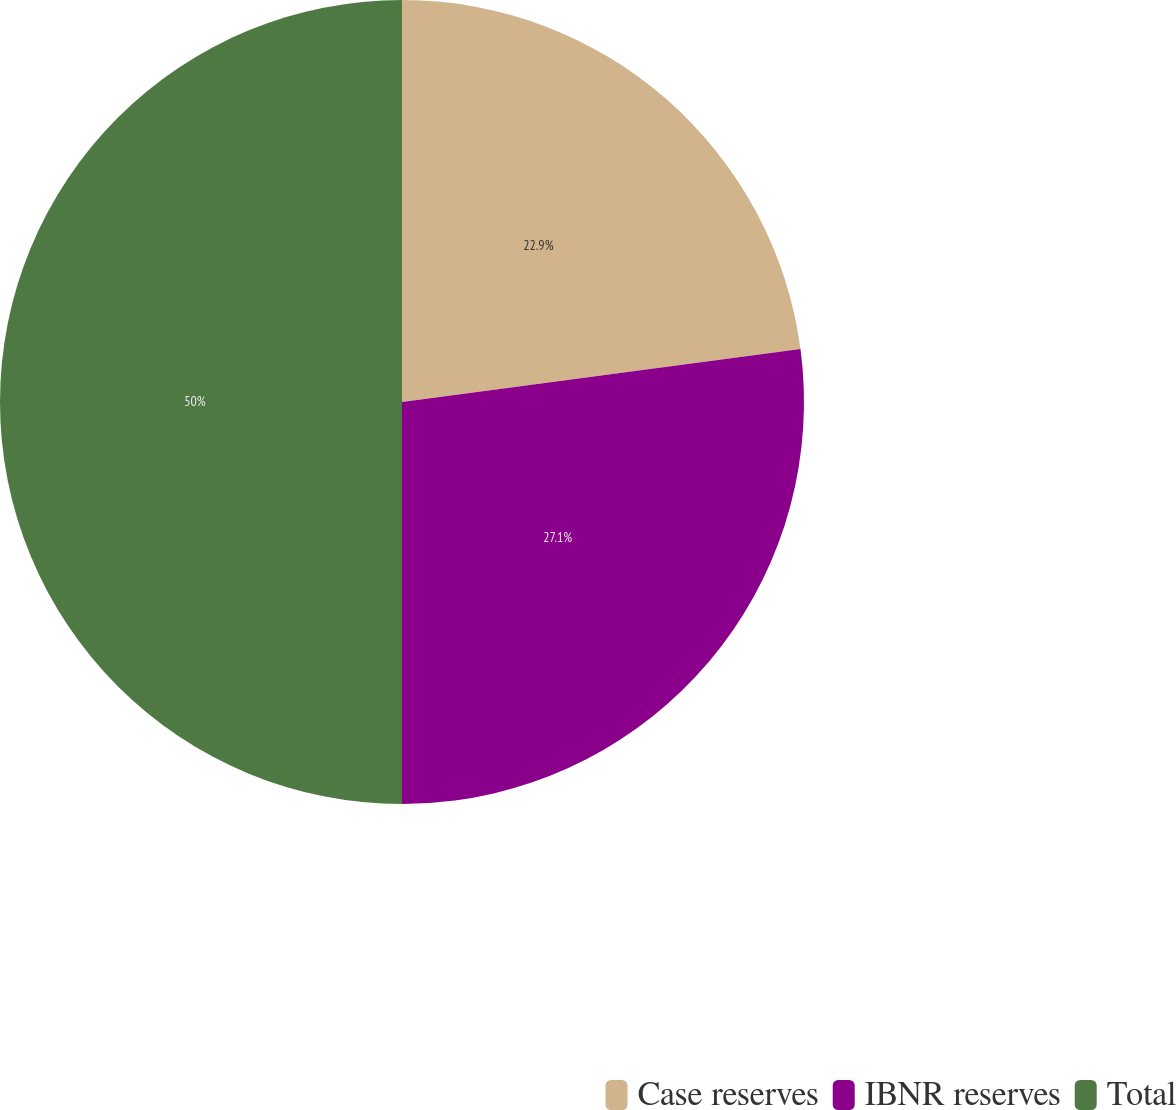Convert chart to OTSL. <chart><loc_0><loc_0><loc_500><loc_500><pie_chart><fcel>Case reserves<fcel>IBNR reserves<fcel>Total<nl><fcel>22.9%<fcel>27.1%<fcel>50.0%<nl></chart> 